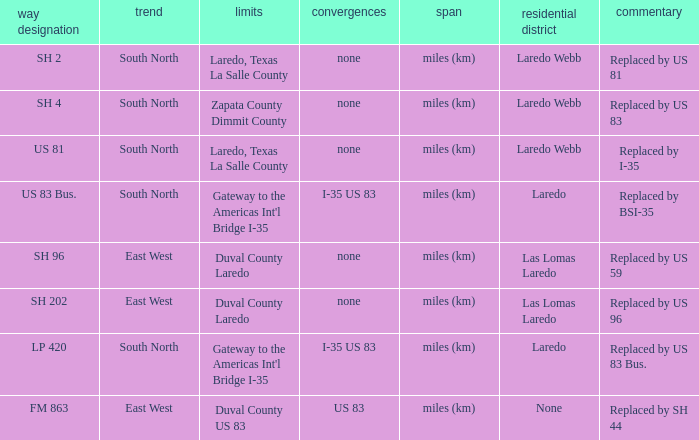How many junctions have "replaced by bsi-35" listed in their remarks section? 1.0. 